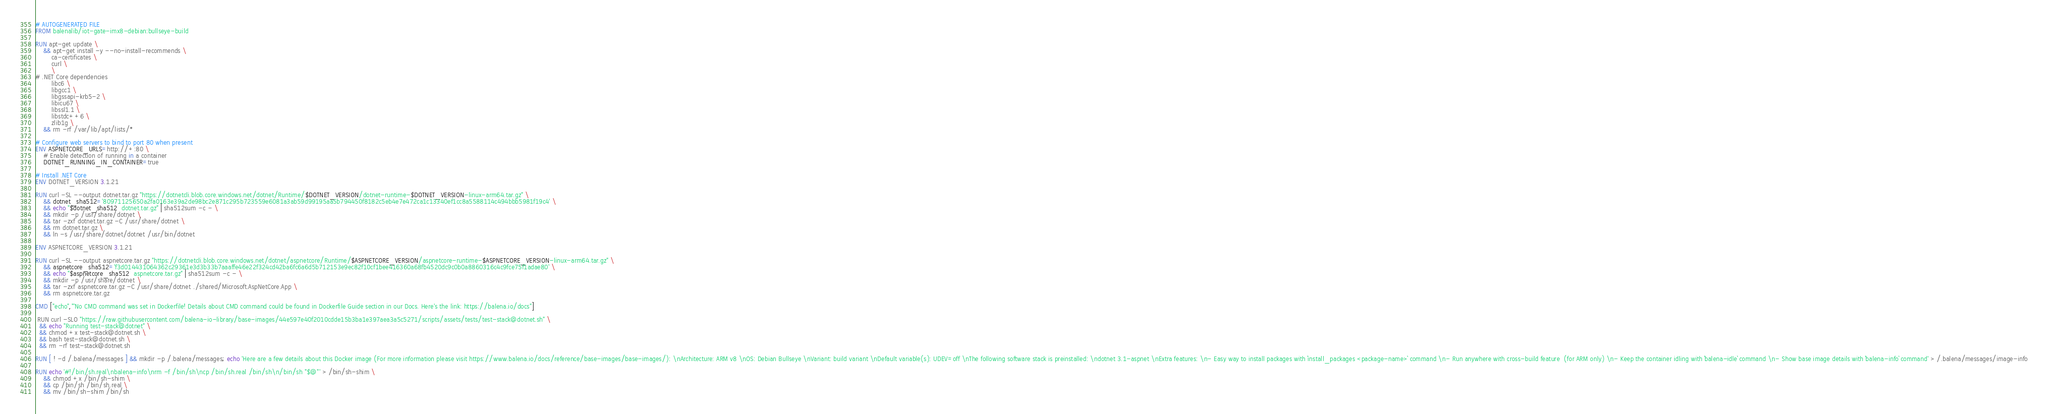<code> <loc_0><loc_0><loc_500><loc_500><_Dockerfile_># AUTOGENERATED FILE
FROM balenalib/iot-gate-imx8-debian:bullseye-build

RUN apt-get update \
    && apt-get install -y --no-install-recommends \
        ca-certificates \
        curl \
        \
# .NET Core dependencies
        libc6 \
        libgcc1 \
        libgssapi-krb5-2 \
        libicu67 \
        libssl1.1 \
        libstdc++6 \
        zlib1g \
    && rm -rf /var/lib/apt/lists/*

# Configure web servers to bind to port 80 when present
ENV ASPNETCORE_URLS=http://+:80 \
    # Enable detection of running in a container
    DOTNET_RUNNING_IN_CONTAINER=true

# Install .NET Core
ENV DOTNET_VERSION 3.1.21

RUN curl -SL --output dotnet.tar.gz "https://dotnetcli.blob.core.windows.net/dotnet/Runtime/$DOTNET_VERSION/dotnet-runtime-$DOTNET_VERSION-linux-arm64.tar.gz" \
    && dotnet_sha512='80971125650a2fa0163e39a2de98bc2e871c295b723559e6081a3ab59d99195aa5b794450f8182c5eb4e7e472ca1c13340ef1cc8a5588114c494bbb5981f19c4' \
    && echo "$dotnet_sha512  dotnet.tar.gz" | sha512sum -c - \
    && mkdir -p /usr/share/dotnet \
    && tar -zxf dotnet.tar.gz -C /usr/share/dotnet \
    && rm dotnet.tar.gz \
    && ln -s /usr/share/dotnet/dotnet /usr/bin/dotnet

ENV ASPNETCORE_VERSION 3.1.21

RUN curl -SL --output aspnetcore.tar.gz "https://dotnetcli.blob.core.windows.net/dotnet/aspnetcore/Runtime/$ASPNETCORE_VERSION/aspnetcore-runtime-$ASPNETCORE_VERSION-linux-arm64.tar.gz" \
    && aspnetcore_sha512='f3d014431064362c29361e3d3b33b7aaaffe46e22f324cd42ba6fc6a6d5b712153e9ec82f10cf1bee416360a68fb4520dc9c0b0a8860316c4c9fce75f1adae80' \
    && echo "$aspnetcore_sha512  aspnetcore.tar.gz" | sha512sum -c - \
    && mkdir -p /usr/share/dotnet \
    && tar -zxf aspnetcore.tar.gz -C /usr/share/dotnet ./shared/Microsoft.AspNetCore.App \
    && rm aspnetcore.tar.gz

CMD ["echo","'No CMD command was set in Dockerfile! Details about CMD command could be found in Dockerfile Guide section in our Docs. Here's the link: https://balena.io/docs"]

 RUN curl -SLO "https://raw.githubusercontent.com/balena-io-library/base-images/44e597e40f2010cdde15b3ba1e397aea3a5c5271/scripts/assets/tests/test-stack@dotnet.sh" \
  && echo "Running test-stack@dotnet" \
  && chmod +x test-stack@dotnet.sh \
  && bash test-stack@dotnet.sh \
  && rm -rf test-stack@dotnet.sh 

RUN [ ! -d /.balena/messages ] && mkdir -p /.balena/messages; echo 'Here are a few details about this Docker image (For more information please visit https://www.balena.io/docs/reference/base-images/base-images/): \nArchitecture: ARM v8 \nOS: Debian Bullseye \nVariant: build variant \nDefault variable(s): UDEV=off \nThe following software stack is preinstalled: \ndotnet 3.1-aspnet \nExtra features: \n- Easy way to install packages with `install_packages <package-name>` command \n- Run anywhere with cross-build feature  (for ARM only) \n- Keep the container idling with `balena-idle` command \n- Show base image details with `balena-info` command' > /.balena/messages/image-info

RUN echo '#!/bin/sh.real\nbalena-info\nrm -f /bin/sh\ncp /bin/sh.real /bin/sh\n/bin/sh "$@"' > /bin/sh-shim \
	&& chmod +x /bin/sh-shim \
	&& cp /bin/sh /bin/sh.real \
	&& mv /bin/sh-shim /bin/sh</code> 